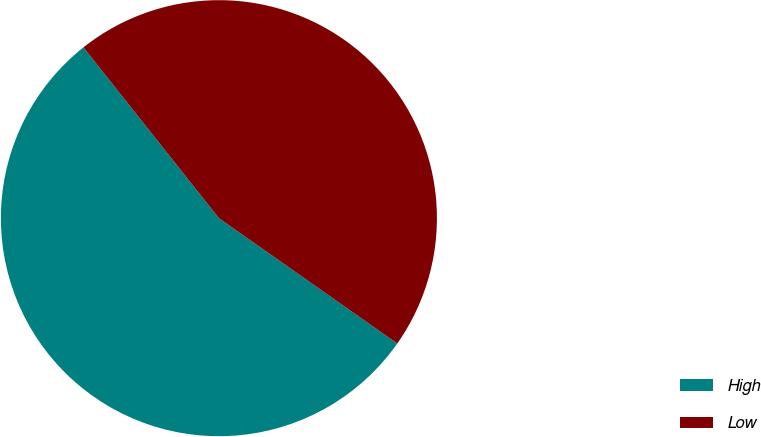<chart> <loc_0><loc_0><loc_500><loc_500><pie_chart><fcel>High<fcel>Low<nl><fcel>54.58%<fcel>45.42%<nl></chart> 